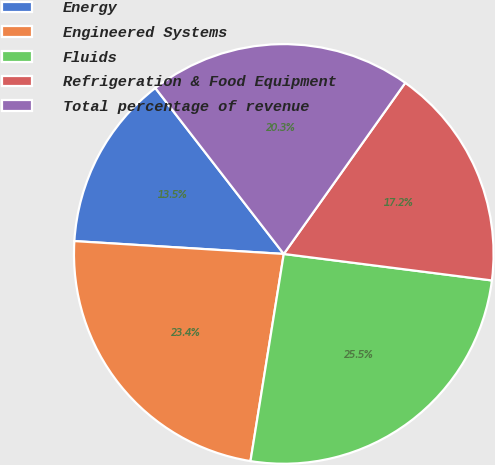Convert chart to OTSL. <chart><loc_0><loc_0><loc_500><loc_500><pie_chart><fcel>Energy<fcel>Engineered Systems<fcel>Fluids<fcel>Refrigeration & Food Equipment<fcel>Total percentage of revenue<nl><fcel>13.54%<fcel>23.44%<fcel>25.52%<fcel>17.19%<fcel>20.31%<nl></chart> 